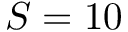<formula> <loc_0><loc_0><loc_500><loc_500>S = 1 0</formula> 